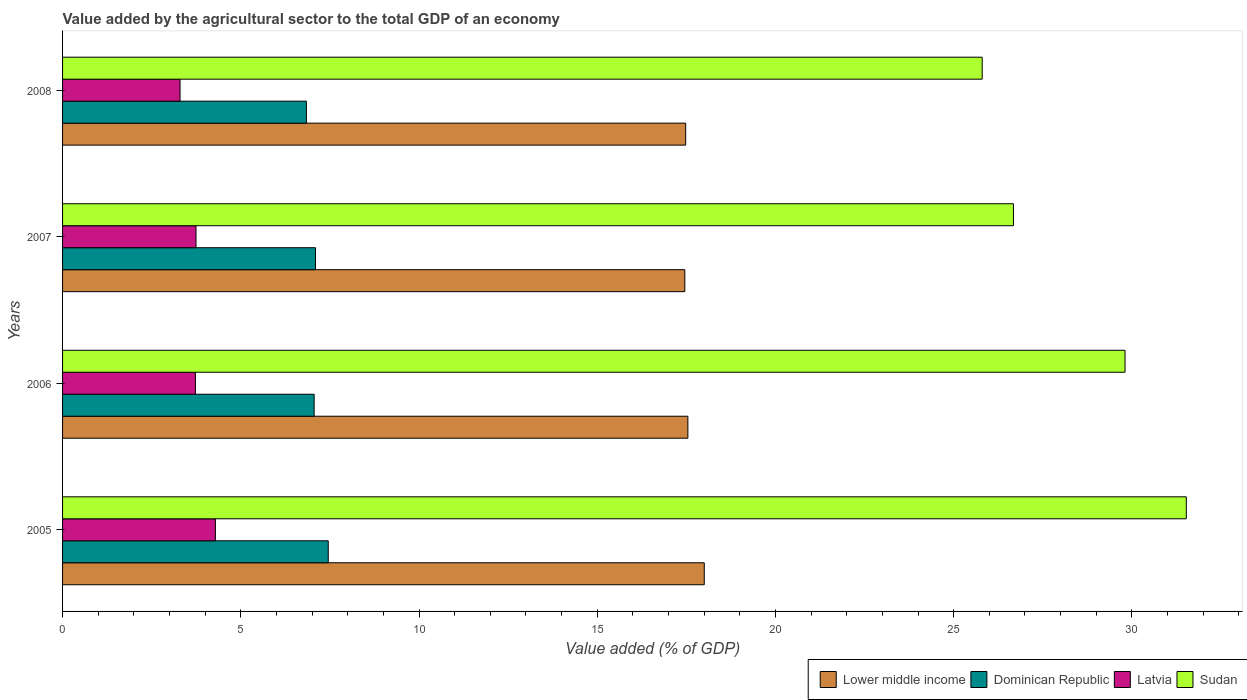How many different coloured bars are there?
Your response must be concise. 4. Are the number of bars per tick equal to the number of legend labels?
Your response must be concise. Yes. What is the label of the 3rd group of bars from the top?
Keep it short and to the point. 2006. What is the value added by the agricultural sector to the total GDP in Latvia in 2005?
Your answer should be very brief. 4.29. Across all years, what is the maximum value added by the agricultural sector to the total GDP in Sudan?
Provide a short and direct response. 31.53. Across all years, what is the minimum value added by the agricultural sector to the total GDP in Lower middle income?
Offer a very short reply. 17.46. In which year was the value added by the agricultural sector to the total GDP in Sudan minimum?
Give a very brief answer. 2008. What is the total value added by the agricultural sector to the total GDP in Dominican Republic in the graph?
Your answer should be compact. 28.45. What is the difference between the value added by the agricultural sector to the total GDP in Sudan in 2005 and that in 2007?
Provide a succinct answer. 4.85. What is the difference between the value added by the agricultural sector to the total GDP in Latvia in 2006 and the value added by the agricultural sector to the total GDP in Dominican Republic in 2007?
Provide a succinct answer. -3.37. What is the average value added by the agricultural sector to the total GDP in Latvia per year?
Your answer should be compact. 3.76. In the year 2008, what is the difference between the value added by the agricultural sector to the total GDP in Latvia and value added by the agricultural sector to the total GDP in Sudan?
Offer a terse response. -22.51. What is the ratio of the value added by the agricultural sector to the total GDP in Dominican Republic in 2007 to that in 2008?
Your response must be concise. 1.04. What is the difference between the highest and the second highest value added by the agricultural sector to the total GDP in Latvia?
Give a very brief answer. 0.54. What is the difference between the highest and the lowest value added by the agricultural sector to the total GDP in Sudan?
Your response must be concise. 5.73. What does the 4th bar from the top in 2008 represents?
Ensure brevity in your answer.  Lower middle income. What does the 2nd bar from the bottom in 2005 represents?
Your answer should be very brief. Dominican Republic. Is it the case that in every year, the sum of the value added by the agricultural sector to the total GDP in Sudan and value added by the agricultural sector to the total GDP in Lower middle income is greater than the value added by the agricultural sector to the total GDP in Latvia?
Ensure brevity in your answer.  Yes. How many years are there in the graph?
Provide a succinct answer. 4. What is the difference between two consecutive major ticks on the X-axis?
Your response must be concise. 5. Does the graph contain any zero values?
Your response must be concise. No. Where does the legend appear in the graph?
Your answer should be very brief. Bottom right. How many legend labels are there?
Give a very brief answer. 4. What is the title of the graph?
Give a very brief answer. Value added by the agricultural sector to the total GDP of an economy. Does "Albania" appear as one of the legend labels in the graph?
Your response must be concise. No. What is the label or title of the X-axis?
Offer a terse response. Value added (% of GDP). What is the Value added (% of GDP) of Lower middle income in 2005?
Provide a short and direct response. 18. What is the Value added (% of GDP) in Dominican Republic in 2005?
Provide a short and direct response. 7.45. What is the Value added (% of GDP) in Latvia in 2005?
Give a very brief answer. 4.29. What is the Value added (% of GDP) of Sudan in 2005?
Make the answer very short. 31.53. What is the Value added (% of GDP) of Lower middle income in 2006?
Provide a short and direct response. 17.54. What is the Value added (% of GDP) of Dominican Republic in 2006?
Offer a terse response. 7.06. What is the Value added (% of GDP) of Latvia in 2006?
Give a very brief answer. 3.73. What is the Value added (% of GDP) of Sudan in 2006?
Your answer should be compact. 29.81. What is the Value added (% of GDP) of Lower middle income in 2007?
Give a very brief answer. 17.46. What is the Value added (% of GDP) in Dominican Republic in 2007?
Give a very brief answer. 7.1. What is the Value added (% of GDP) of Latvia in 2007?
Your response must be concise. 3.74. What is the Value added (% of GDP) in Sudan in 2007?
Your answer should be compact. 26.68. What is the Value added (% of GDP) in Lower middle income in 2008?
Offer a very short reply. 17.48. What is the Value added (% of GDP) in Dominican Republic in 2008?
Your response must be concise. 6.84. What is the Value added (% of GDP) in Latvia in 2008?
Give a very brief answer. 3.3. What is the Value added (% of GDP) of Sudan in 2008?
Offer a terse response. 25.8. Across all years, what is the maximum Value added (% of GDP) in Lower middle income?
Offer a terse response. 18. Across all years, what is the maximum Value added (% of GDP) in Dominican Republic?
Provide a succinct answer. 7.45. Across all years, what is the maximum Value added (% of GDP) of Latvia?
Your answer should be very brief. 4.29. Across all years, what is the maximum Value added (% of GDP) of Sudan?
Offer a terse response. 31.53. Across all years, what is the minimum Value added (% of GDP) in Lower middle income?
Keep it short and to the point. 17.46. Across all years, what is the minimum Value added (% of GDP) of Dominican Republic?
Offer a terse response. 6.84. Across all years, what is the minimum Value added (% of GDP) of Latvia?
Offer a terse response. 3.3. Across all years, what is the minimum Value added (% of GDP) in Sudan?
Keep it short and to the point. 25.8. What is the total Value added (% of GDP) in Lower middle income in the graph?
Make the answer very short. 70.49. What is the total Value added (% of GDP) in Dominican Republic in the graph?
Your answer should be very brief. 28.45. What is the total Value added (% of GDP) in Latvia in the graph?
Give a very brief answer. 15.05. What is the total Value added (% of GDP) of Sudan in the graph?
Your response must be concise. 113.82. What is the difference between the Value added (% of GDP) of Lower middle income in 2005 and that in 2006?
Your answer should be very brief. 0.46. What is the difference between the Value added (% of GDP) of Dominican Republic in 2005 and that in 2006?
Your answer should be very brief. 0.4. What is the difference between the Value added (% of GDP) in Latvia in 2005 and that in 2006?
Your answer should be compact. 0.56. What is the difference between the Value added (% of GDP) of Sudan in 2005 and that in 2006?
Your answer should be very brief. 1.72. What is the difference between the Value added (% of GDP) of Lower middle income in 2005 and that in 2007?
Make the answer very short. 0.55. What is the difference between the Value added (% of GDP) in Dominican Republic in 2005 and that in 2007?
Offer a very short reply. 0.36. What is the difference between the Value added (% of GDP) of Latvia in 2005 and that in 2007?
Make the answer very short. 0.54. What is the difference between the Value added (% of GDP) in Sudan in 2005 and that in 2007?
Make the answer very short. 4.85. What is the difference between the Value added (% of GDP) in Lower middle income in 2005 and that in 2008?
Provide a short and direct response. 0.52. What is the difference between the Value added (% of GDP) in Dominican Republic in 2005 and that in 2008?
Provide a short and direct response. 0.61. What is the difference between the Value added (% of GDP) of Sudan in 2005 and that in 2008?
Your response must be concise. 5.73. What is the difference between the Value added (% of GDP) of Lower middle income in 2006 and that in 2007?
Ensure brevity in your answer.  0.09. What is the difference between the Value added (% of GDP) of Dominican Republic in 2006 and that in 2007?
Provide a short and direct response. -0.04. What is the difference between the Value added (% of GDP) of Latvia in 2006 and that in 2007?
Offer a terse response. -0.02. What is the difference between the Value added (% of GDP) of Sudan in 2006 and that in 2007?
Ensure brevity in your answer.  3.13. What is the difference between the Value added (% of GDP) of Lower middle income in 2006 and that in 2008?
Make the answer very short. 0.06. What is the difference between the Value added (% of GDP) of Dominican Republic in 2006 and that in 2008?
Provide a short and direct response. 0.22. What is the difference between the Value added (% of GDP) of Latvia in 2006 and that in 2008?
Give a very brief answer. 0.43. What is the difference between the Value added (% of GDP) of Sudan in 2006 and that in 2008?
Provide a succinct answer. 4.01. What is the difference between the Value added (% of GDP) in Lower middle income in 2007 and that in 2008?
Make the answer very short. -0.02. What is the difference between the Value added (% of GDP) of Dominican Republic in 2007 and that in 2008?
Your answer should be compact. 0.26. What is the difference between the Value added (% of GDP) of Latvia in 2007 and that in 2008?
Make the answer very short. 0.45. What is the difference between the Value added (% of GDP) in Sudan in 2007 and that in 2008?
Ensure brevity in your answer.  0.88. What is the difference between the Value added (% of GDP) in Lower middle income in 2005 and the Value added (% of GDP) in Dominican Republic in 2006?
Offer a very short reply. 10.95. What is the difference between the Value added (% of GDP) of Lower middle income in 2005 and the Value added (% of GDP) of Latvia in 2006?
Provide a succinct answer. 14.28. What is the difference between the Value added (% of GDP) in Lower middle income in 2005 and the Value added (% of GDP) in Sudan in 2006?
Your response must be concise. -11.81. What is the difference between the Value added (% of GDP) of Dominican Republic in 2005 and the Value added (% of GDP) of Latvia in 2006?
Give a very brief answer. 3.73. What is the difference between the Value added (% of GDP) of Dominican Republic in 2005 and the Value added (% of GDP) of Sudan in 2006?
Offer a very short reply. -22.35. What is the difference between the Value added (% of GDP) of Latvia in 2005 and the Value added (% of GDP) of Sudan in 2006?
Provide a succinct answer. -25.52. What is the difference between the Value added (% of GDP) in Lower middle income in 2005 and the Value added (% of GDP) in Dominican Republic in 2007?
Provide a short and direct response. 10.91. What is the difference between the Value added (% of GDP) of Lower middle income in 2005 and the Value added (% of GDP) of Latvia in 2007?
Your answer should be very brief. 14.26. What is the difference between the Value added (% of GDP) of Lower middle income in 2005 and the Value added (% of GDP) of Sudan in 2007?
Give a very brief answer. -8.67. What is the difference between the Value added (% of GDP) of Dominican Republic in 2005 and the Value added (% of GDP) of Latvia in 2007?
Your response must be concise. 3.71. What is the difference between the Value added (% of GDP) in Dominican Republic in 2005 and the Value added (% of GDP) in Sudan in 2007?
Your answer should be very brief. -19.22. What is the difference between the Value added (% of GDP) of Latvia in 2005 and the Value added (% of GDP) of Sudan in 2007?
Ensure brevity in your answer.  -22.39. What is the difference between the Value added (% of GDP) of Lower middle income in 2005 and the Value added (% of GDP) of Dominican Republic in 2008?
Keep it short and to the point. 11.16. What is the difference between the Value added (% of GDP) of Lower middle income in 2005 and the Value added (% of GDP) of Latvia in 2008?
Your answer should be compact. 14.71. What is the difference between the Value added (% of GDP) of Lower middle income in 2005 and the Value added (% of GDP) of Sudan in 2008?
Make the answer very short. -7.8. What is the difference between the Value added (% of GDP) in Dominican Republic in 2005 and the Value added (% of GDP) in Latvia in 2008?
Offer a terse response. 4.16. What is the difference between the Value added (% of GDP) in Dominican Republic in 2005 and the Value added (% of GDP) in Sudan in 2008?
Your answer should be very brief. -18.35. What is the difference between the Value added (% of GDP) in Latvia in 2005 and the Value added (% of GDP) in Sudan in 2008?
Provide a succinct answer. -21.51. What is the difference between the Value added (% of GDP) in Lower middle income in 2006 and the Value added (% of GDP) in Dominican Republic in 2007?
Provide a succinct answer. 10.45. What is the difference between the Value added (% of GDP) of Lower middle income in 2006 and the Value added (% of GDP) of Latvia in 2007?
Make the answer very short. 13.8. What is the difference between the Value added (% of GDP) in Lower middle income in 2006 and the Value added (% of GDP) in Sudan in 2007?
Give a very brief answer. -9.13. What is the difference between the Value added (% of GDP) of Dominican Republic in 2006 and the Value added (% of GDP) of Latvia in 2007?
Provide a short and direct response. 3.31. What is the difference between the Value added (% of GDP) of Dominican Republic in 2006 and the Value added (% of GDP) of Sudan in 2007?
Offer a very short reply. -19.62. What is the difference between the Value added (% of GDP) in Latvia in 2006 and the Value added (% of GDP) in Sudan in 2007?
Give a very brief answer. -22.95. What is the difference between the Value added (% of GDP) in Lower middle income in 2006 and the Value added (% of GDP) in Dominican Republic in 2008?
Make the answer very short. 10.7. What is the difference between the Value added (% of GDP) of Lower middle income in 2006 and the Value added (% of GDP) of Latvia in 2008?
Offer a terse response. 14.25. What is the difference between the Value added (% of GDP) of Lower middle income in 2006 and the Value added (% of GDP) of Sudan in 2008?
Your answer should be very brief. -8.26. What is the difference between the Value added (% of GDP) in Dominican Republic in 2006 and the Value added (% of GDP) in Latvia in 2008?
Make the answer very short. 3.76. What is the difference between the Value added (% of GDP) of Dominican Republic in 2006 and the Value added (% of GDP) of Sudan in 2008?
Offer a very short reply. -18.74. What is the difference between the Value added (% of GDP) of Latvia in 2006 and the Value added (% of GDP) of Sudan in 2008?
Ensure brevity in your answer.  -22.07. What is the difference between the Value added (% of GDP) of Lower middle income in 2007 and the Value added (% of GDP) of Dominican Republic in 2008?
Give a very brief answer. 10.62. What is the difference between the Value added (% of GDP) of Lower middle income in 2007 and the Value added (% of GDP) of Latvia in 2008?
Your answer should be very brief. 14.16. What is the difference between the Value added (% of GDP) in Lower middle income in 2007 and the Value added (% of GDP) in Sudan in 2008?
Ensure brevity in your answer.  -8.34. What is the difference between the Value added (% of GDP) in Dominican Republic in 2007 and the Value added (% of GDP) in Latvia in 2008?
Provide a short and direct response. 3.8. What is the difference between the Value added (% of GDP) of Dominican Republic in 2007 and the Value added (% of GDP) of Sudan in 2008?
Your response must be concise. -18.7. What is the difference between the Value added (% of GDP) in Latvia in 2007 and the Value added (% of GDP) in Sudan in 2008?
Give a very brief answer. -22.06. What is the average Value added (% of GDP) in Lower middle income per year?
Offer a very short reply. 17.62. What is the average Value added (% of GDP) of Dominican Republic per year?
Provide a short and direct response. 7.11. What is the average Value added (% of GDP) of Latvia per year?
Make the answer very short. 3.76. What is the average Value added (% of GDP) in Sudan per year?
Make the answer very short. 28.45. In the year 2005, what is the difference between the Value added (% of GDP) in Lower middle income and Value added (% of GDP) in Dominican Republic?
Provide a succinct answer. 10.55. In the year 2005, what is the difference between the Value added (% of GDP) in Lower middle income and Value added (% of GDP) in Latvia?
Ensure brevity in your answer.  13.72. In the year 2005, what is the difference between the Value added (% of GDP) in Lower middle income and Value added (% of GDP) in Sudan?
Keep it short and to the point. -13.52. In the year 2005, what is the difference between the Value added (% of GDP) in Dominican Republic and Value added (% of GDP) in Latvia?
Offer a terse response. 3.17. In the year 2005, what is the difference between the Value added (% of GDP) in Dominican Republic and Value added (% of GDP) in Sudan?
Your answer should be compact. -24.07. In the year 2005, what is the difference between the Value added (% of GDP) in Latvia and Value added (% of GDP) in Sudan?
Provide a succinct answer. -27.24. In the year 2006, what is the difference between the Value added (% of GDP) in Lower middle income and Value added (% of GDP) in Dominican Republic?
Your answer should be compact. 10.49. In the year 2006, what is the difference between the Value added (% of GDP) in Lower middle income and Value added (% of GDP) in Latvia?
Ensure brevity in your answer.  13.82. In the year 2006, what is the difference between the Value added (% of GDP) in Lower middle income and Value added (% of GDP) in Sudan?
Offer a terse response. -12.26. In the year 2006, what is the difference between the Value added (% of GDP) in Dominican Republic and Value added (% of GDP) in Latvia?
Keep it short and to the point. 3.33. In the year 2006, what is the difference between the Value added (% of GDP) of Dominican Republic and Value added (% of GDP) of Sudan?
Keep it short and to the point. -22.75. In the year 2006, what is the difference between the Value added (% of GDP) of Latvia and Value added (% of GDP) of Sudan?
Make the answer very short. -26.08. In the year 2007, what is the difference between the Value added (% of GDP) in Lower middle income and Value added (% of GDP) in Dominican Republic?
Keep it short and to the point. 10.36. In the year 2007, what is the difference between the Value added (% of GDP) of Lower middle income and Value added (% of GDP) of Latvia?
Keep it short and to the point. 13.71. In the year 2007, what is the difference between the Value added (% of GDP) in Lower middle income and Value added (% of GDP) in Sudan?
Keep it short and to the point. -9.22. In the year 2007, what is the difference between the Value added (% of GDP) of Dominican Republic and Value added (% of GDP) of Latvia?
Provide a short and direct response. 3.35. In the year 2007, what is the difference between the Value added (% of GDP) in Dominican Republic and Value added (% of GDP) in Sudan?
Keep it short and to the point. -19.58. In the year 2007, what is the difference between the Value added (% of GDP) of Latvia and Value added (% of GDP) of Sudan?
Your response must be concise. -22.93. In the year 2008, what is the difference between the Value added (% of GDP) in Lower middle income and Value added (% of GDP) in Dominican Republic?
Keep it short and to the point. 10.64. In the year 2008, what is the difference between the Value added (% of GDP) in Lower middle income and Value added (% of GDP) in Latvia?
Your response must be concise. 14.19. In the year 2008, what is the difference between the Value added (% of GDP) of Lower middle income and Value added (% of GDP) of Sudan?
Your response must be concise. -8.32. In the year 2008, what is the difference between the Value added (% of GDP) in Dominican Republic and Value added (% of GDP) in Latvia?
Provide a succinct answer. 3.55. In the year 2008, what is the difference between the Value added (% of GDP) in Dominican Republic and Value added (% of GDP) in Sudan?
Offer a terse response. -18.96. In the year 2008, what is the difference between the Value added (% of GDP) in Latvia and Value added (% of GDP) in Sudan?
Your response must be concise. -22.51. What is the ratio of the Value added (% of GDP) of Lower middle income in 2005 to that in 2006?
Offer a terse response. 1.03. What is the ratio of the Value added (% of GDP) in Dominican Republic in 2005 to that in 2006?
Offer a terse response. 1.06. What is the ratio of the Value added (% of GDP) of Latvia in 2005 to that in 2006?
Ensure brevity in your answer.  1.15. What is the ratio of the Value added (% of GDP) of Sudan in 2005 to that in 2006?
Offer a very short reply. 1.06. What is the ratio of the Value added (% of GDP) of Lower middle income in 2005 to that in 2007?
Provide a succinct answer. 1.03. What is the ratio of the Value added (% of GDP) in Dominican Republic in 2005 to that in 2007?
Make the answer very short. 1.05. What is the ratio of the Value added (% of GDP) of Latvia in 2005 to that in 2007?
Provide a succinct answer. 1.15. What is the ratio of the Value added (% of GDP) of Sudan in 2005 to that in 2007?
Give a very brief answer. 1.18. What is the ratio of the Value added (% of GDP) of Lower middle income in 2005 to that in 2008?
Offer a terse response. 1.03. What is the ratio of the Value added (% of GDP) of Dominican Republic in 2005 to that in 2008?
Your answer should be compact. 1.09. What is the ratio of the Value added (% of GDP) in Latvia in 2005 to that in 2008?
Offer a very short reply. 1.3. What is the ratio of the Value added (% of GDP) in Sudan in 2005 to that in 2008?
Your response must be concise. 1.22. What is the ratio of the Value added (% of GDP) of Latvia in 2006 to that in 2007?
Offer a very short reply. 1. What is the ratio of the Value added (% of GDP) in Sudan in 2006 to that in 2007?
Your response must be concise. 1.12. What is the ratio of the Value added (% of GDP) in Dominican Republic in 2006 to that in 2008?
Keep it short and to the point. 1.03. What is the ratio of the Value added (% of GDP) of Latvia in 2006 to that in 2008?
Your answer should be very brief. 1.13. What is the ratio of the Value added (% of GDP) in Sudan in 2006 to that in 2008?
Your answer should be very brief. 1.16. What is the ratio of the Value added (% of GDP) of Lower middle income in 2007 to that in 2008?
Provide a succinct answer. 1. What is the ratio of the Value added (% of GDP) of Dominican Republic in 2007 to that in 2008?
Give a very brief answer. 1.04. What is the ratio of the Value added (% of GDP) in Latvia in 2007 to that in 2008?
Offer a terse response. 1.14. What is the ratio of the Value added (% of GDP) of Sudan in 2007 to that in 2008?
Your answer should be compact. 1.03. What is the difference between the highest and the second highest Value added (% of GDP) in Lower middle income?
Your response must be concise. 0.46. What is the difference between the highest and the second highest Value added (% of GDP) of Dominican Republic?
Offer a very short reply. 0.36. What is the difference between the highest and the second highest Value added (% of GDP) in Latvia?
Make the answer very short. 0.54. What is the difference between the highest and the second highest Value added (% of GDP) of Sudan?
Ensure brevity in your answer.  1.72. What is the difference between the highest and the lowest Value added (% of GDP) of Lower middle income?
Your answer should be compact. 0.55. What is the difference between the highest and the lowest Value added (% of GDP) of Dominican Republic?
Give a very brief answer. 0.61. What is the difference between the highest and the lowest Value added (% of GDP) of Sudan?
Provide a short and direct response. 5.73. 